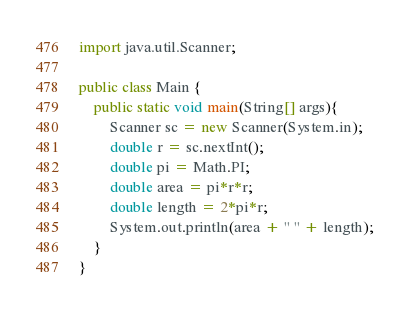<code> <loc_0><loc_0><loc_500><loc_500><_Java_>import java.util.Scanner;

public class Main {
	public static void main(String[] args){
		Scanner sc = new Scanner(System.in);
		double r = sc.nextInt();
		double pi = Math.PI;
		double area = pi*r*r;
		double length = 2*pi*r;
		System.out.println(area + " " + length);
	}
}</code> 